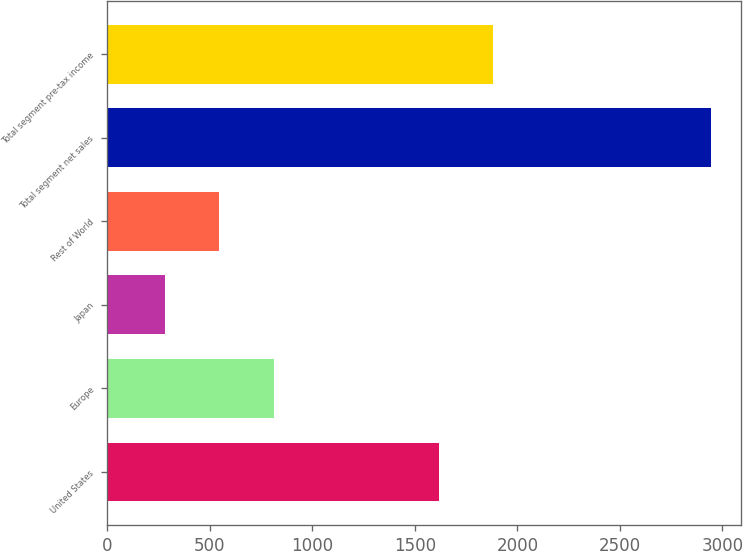Convert chart. <chart><loc_0><loc_0><loc_500><loc_500><bar_chart><fcel>United States<fcel>Europe<fcel>Japan<fcel>Rest of World<fcel>Total segment net sales<fcel>Total segment pre-tax income<nl><fcel>1615.7<fcel>812.64<fcel>279.6<fcel>546.12<fcel>2944.8<fcel>1882.22<nl></chart> 